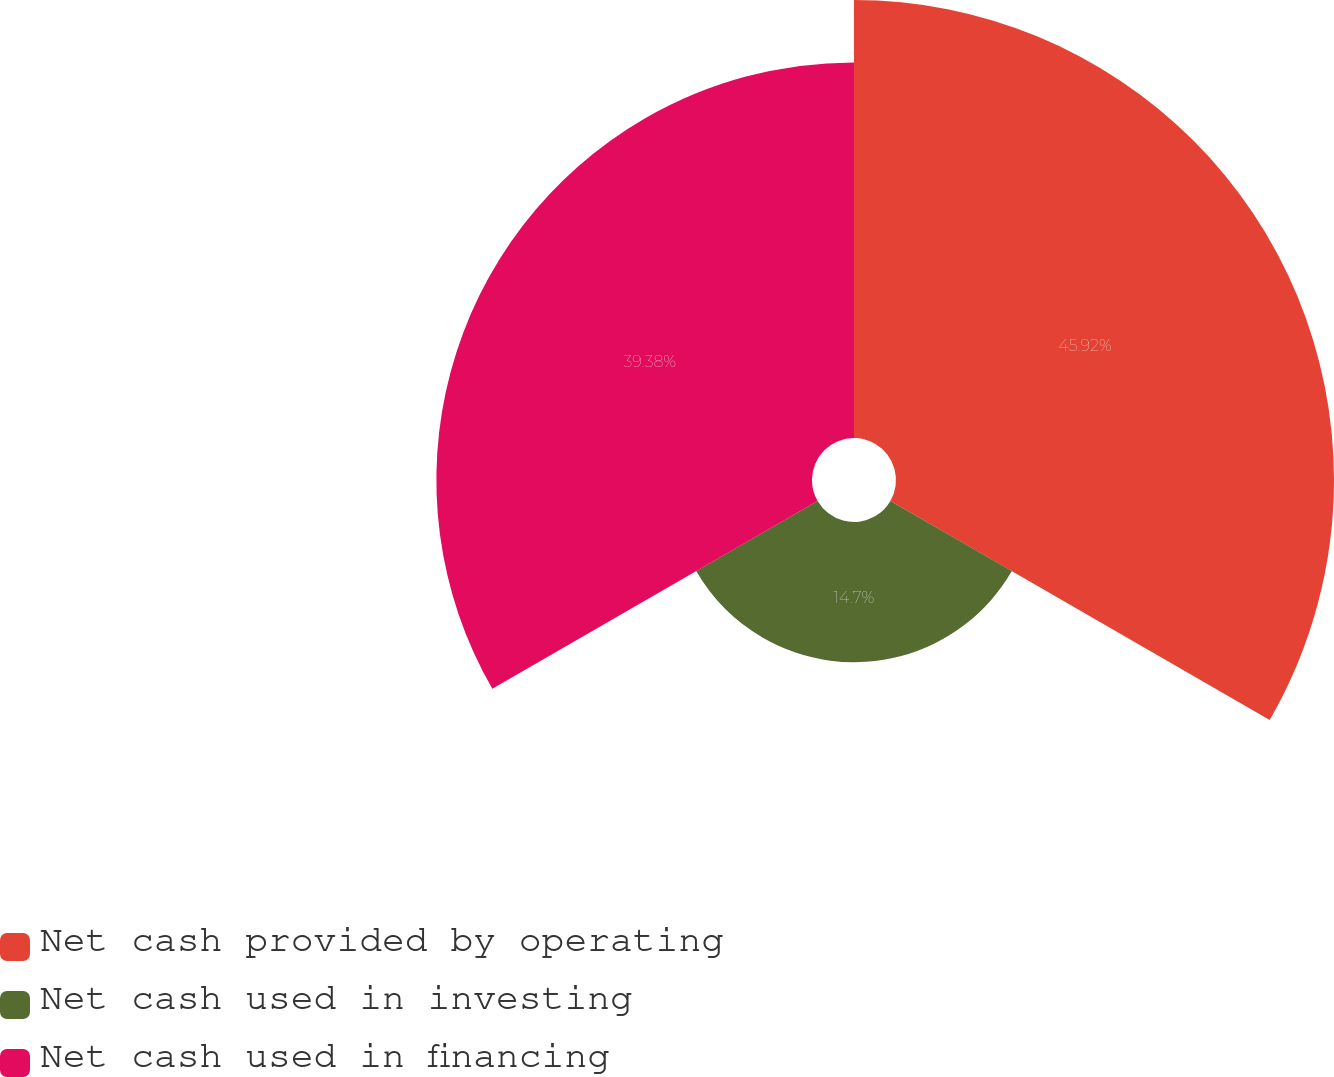<chart> <loc_0><loc_0><loc_500><loc_500><pie_chart><fcel>Net cash provided by operating<fcel>Net cash used in investing<fcel>Net cash used in financing<nl><fcel>45.92%<fcel>14.7%<fcel>39.38%<nl></chart> 